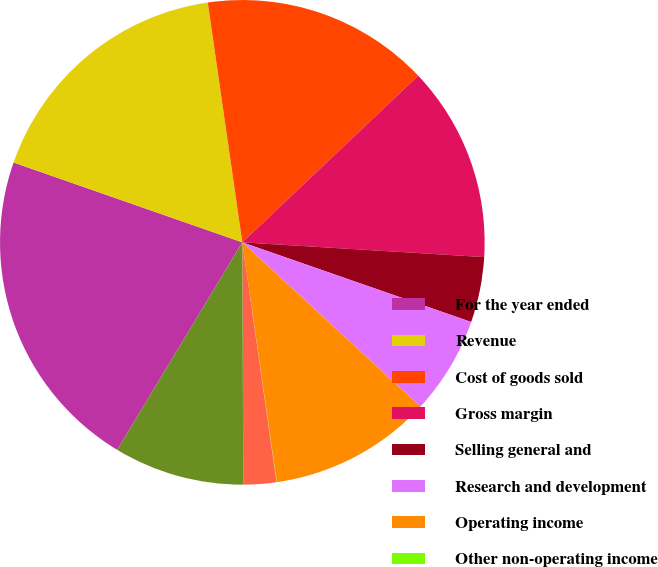Convert chart to OTSL. <chart><loc_0><loc_0><loc_500><loc_500><pie_chart><fcel>For the year ended<fcel>Revenue<fcel>Cost of goods sold<fcel>Gross margin<fcel>Selling general and<fcel>Research and development<fcel>Operating income<fcel>Other non-operating income<fcel>Income tax (provision) benefit<fcel>Net income attributable to<nl><fcel>21.71%<fcel>17.38%<fcel>15.21%<fcel>13.04%<fcel>4.36%<fcel>6.53%<fcel>10.87%<fcel>0.02%<fcel>2.19%<fcel>8.7%<nl></chart> 